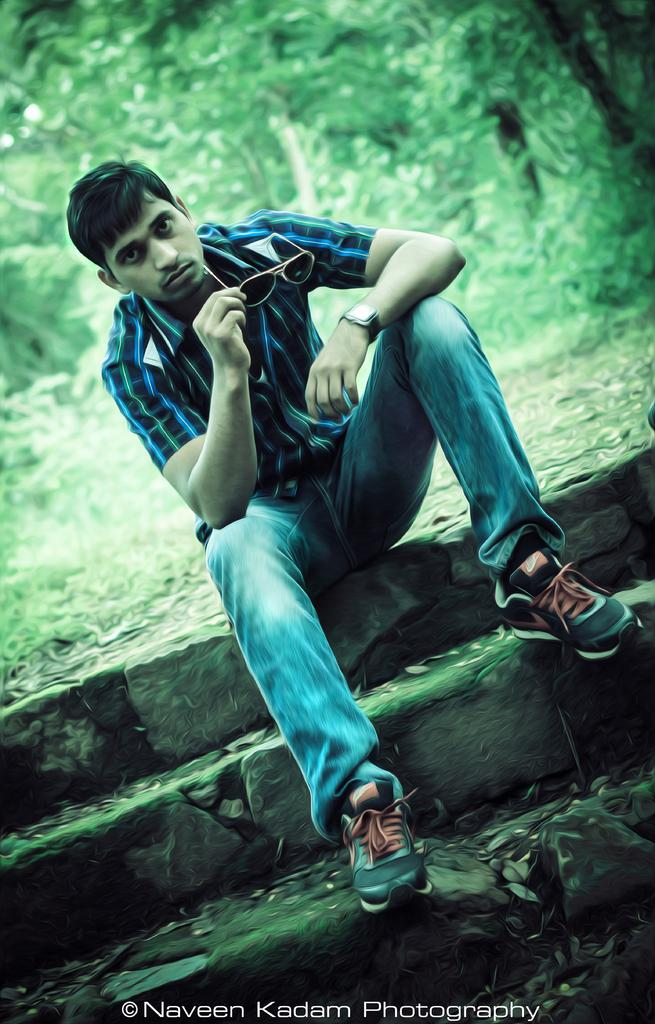What is the person holding in the image? The person is holding goggles. What direction is the person looking in? The person is looking forward. Is there any text or logo visible in the image? Yes, there is a watermark at the bottom of the image. How would you describe the background of the image? The background is blurry, and trees are visible in it. What type of country is being governed by the person in the image? The image does not provide any information about the person's role or the country they might be governing. 